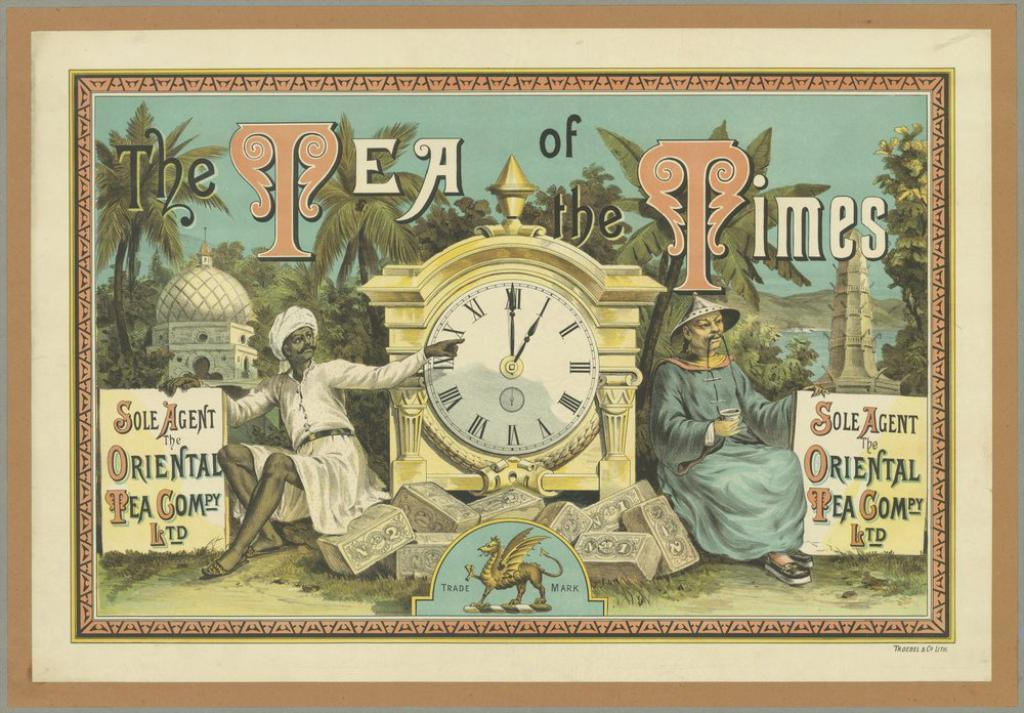<image>
Describe the image concisely. a picture of two men sitting next to a clock entitled a tea of the times 